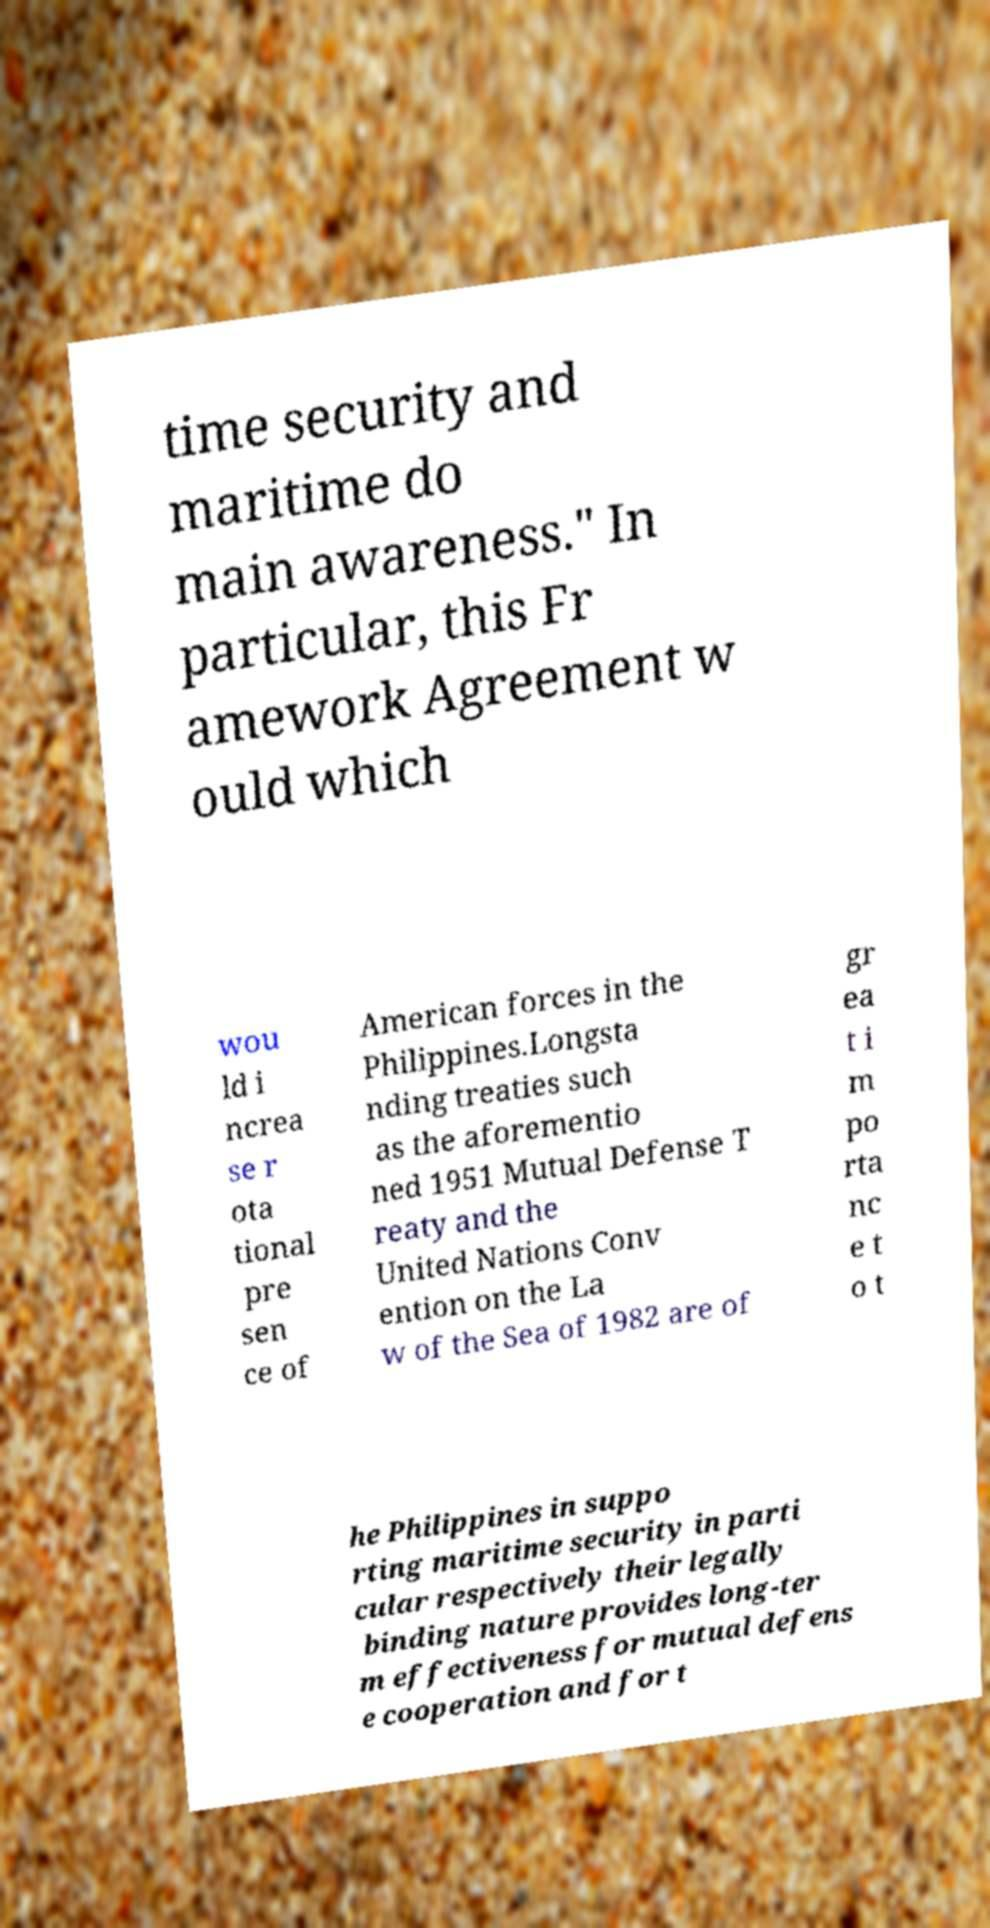What messages or text are displayed in this image? I need them in a readable, typed format. time security and maritime do main awareness." In particular, this Fr amework Agreement w ould which wou ld i ncrea se r ota tional pre sen ce of American forces in the Philippines.Longsta nding treaties such as the aforementio ned 1951 Mutual Defense T reaty and the United Nations Conv ention on the La w of the Sea of 1982 are of gr ea t i m po rta nc e t o t he Philippines in suppo rting maritime security in parti cular respectively their legally binding nature provides long-ter m effectiveness for mutual defens e cooperation and for t 